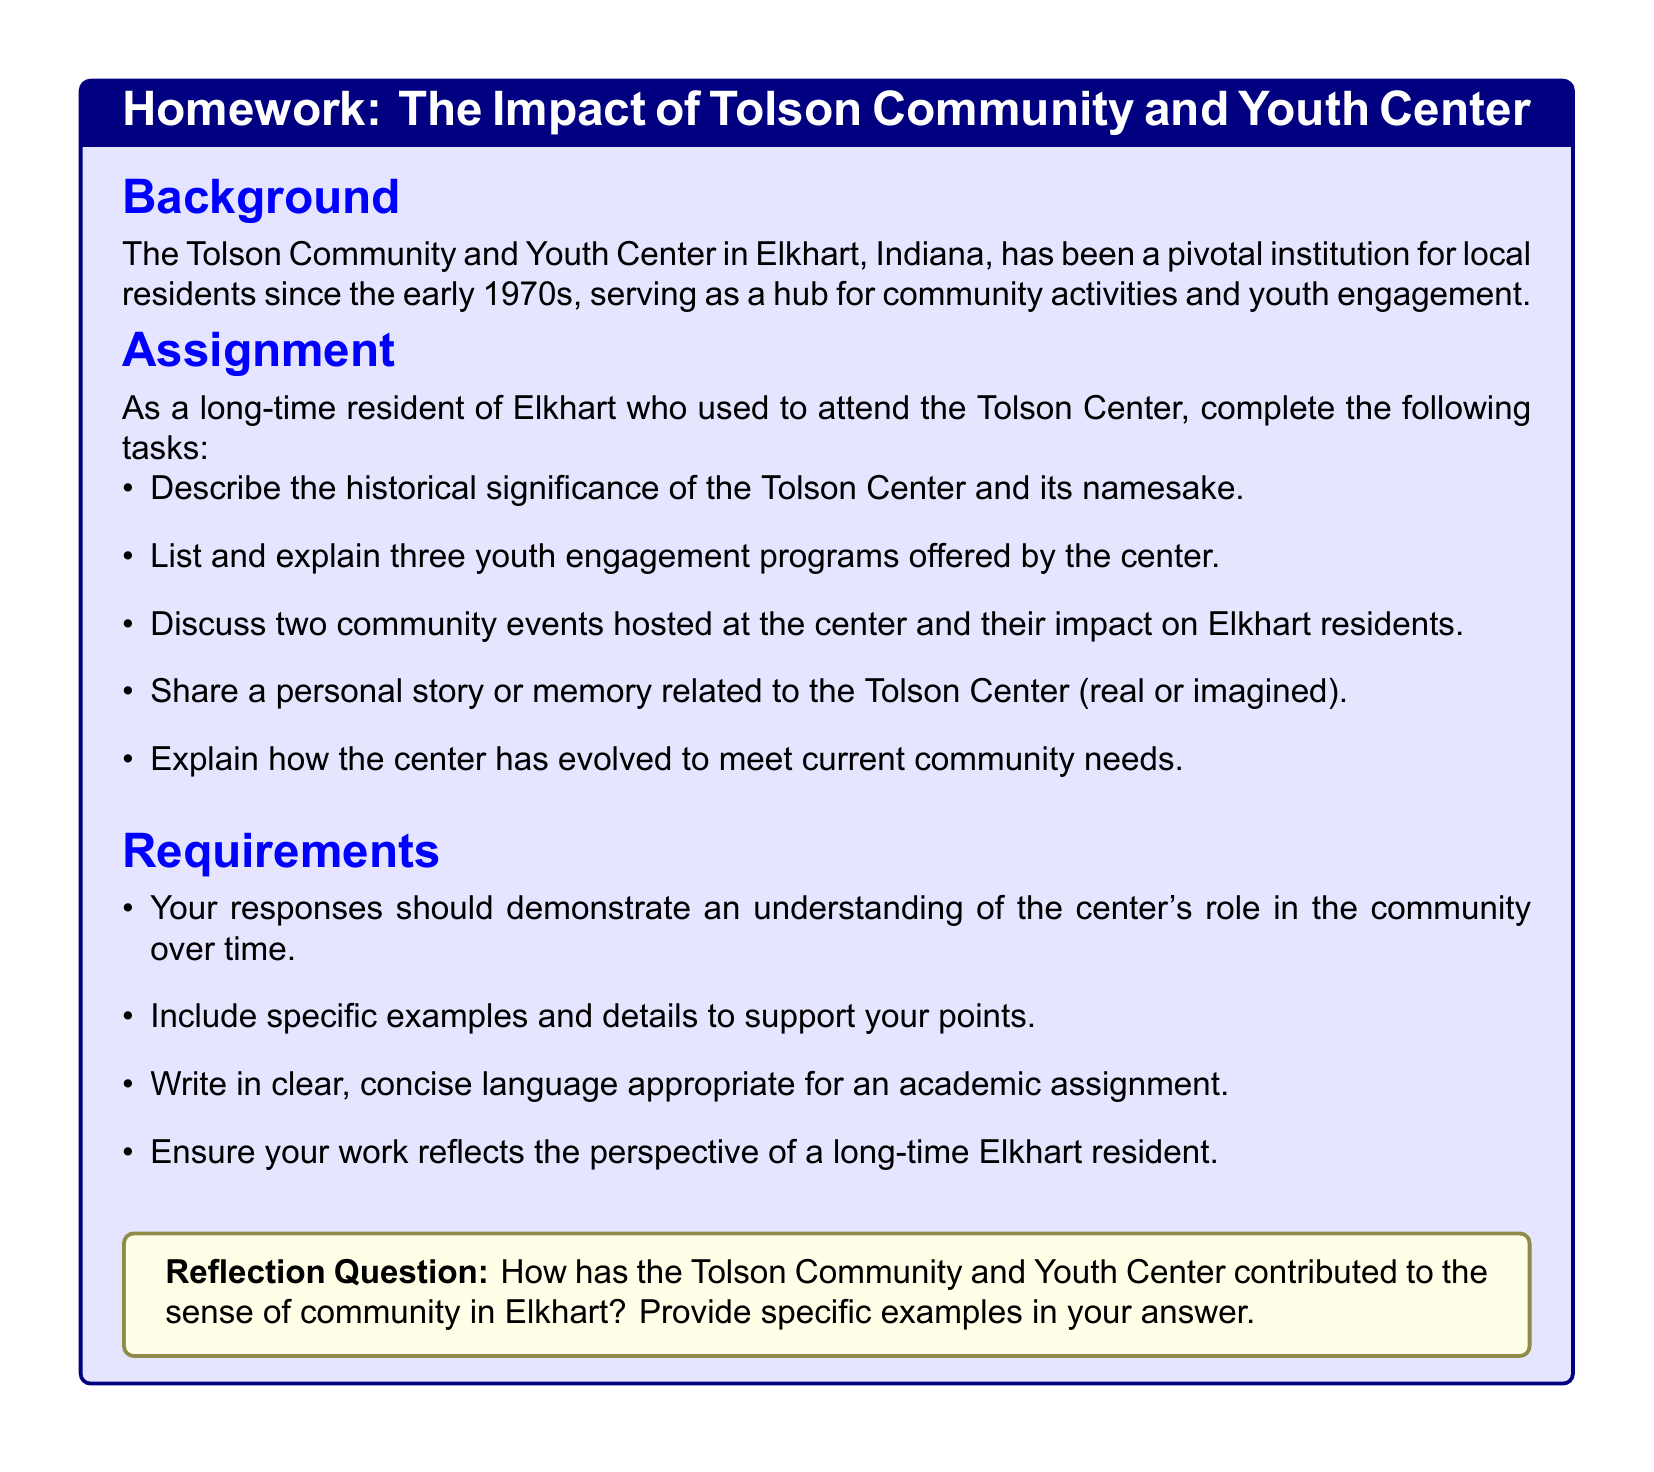What is the historical significance of the Tolson Center? The document states that the Tolson Community and Youth Center has been a pivotal institution for local residents since the early 1970s.
Answer: pivotal institution since the early 1970s What type of center is the Tolson Center? The document identifies the center as a hub for community activities and youth engagement.
Answer: hub for community activities and youth engagement How many youth engagement programs are mentioned? The assignment prompts to list and explain three youth engagement programs, indicating that three programs are relevant.
Answer: three What is one requirement for the assignment? One requirement listed is that responses should demonstrate an understanding of the center's role in the community over time.
Answer: understanding of the center's role What color is used for the background of the tcolorbox? The document uses blue!10 for the background color of the tcolorbox.
Answer: blue!10 Who is the intended audience for this assignment? The assignment is designed for long-time residents of Elkhart who used to attend the Tolson Center.
Answer: long-time residents of Elkhart What are students encouraged to include in their responses? Students are encouraged to include specific examples and details to support their points in their responses.
Answer: specific examples and details What is the nature of the reflection question? It asks how the Tolson Community and Youth Center has contributed to the sense of community in Elkhart, requiring specific examples.
Answer: sense of community in Elkhart What should the language be like for the assignment? The document specifies that the language should be clear and concise, appropriate for an academic assignment.
Answer: clear and concise language 